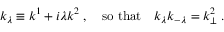<formula> <loc_0><loc_0><loc_500><loc_500>k _ { \lambda } \equiv k ^ { 1 } + i \lambda k ^ { 2 } \, , \quad s o t h a t \quad k _ { \lambda } k _ { - \lambda } = k _ { \perp } ^ { 2 } \, .</formula> 